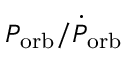Convert formula to latex. <formula><loc_0><loc_0><loc_500><loc_500>P _ { o r b } / \dot { P } _ { o r b }</formula> 